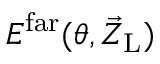<formula> <loc_0><loc_0><loc_500><loc_500>E ^ { f a r } ( \theta , \vec { Z } _ { L } )</formula> 